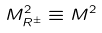<formula> <loc_0><loc_0><loc_500><loc_500>M ^ { 2 } _ { R ^ { \pm } } \equiv M ^ { 2 }</formula> 